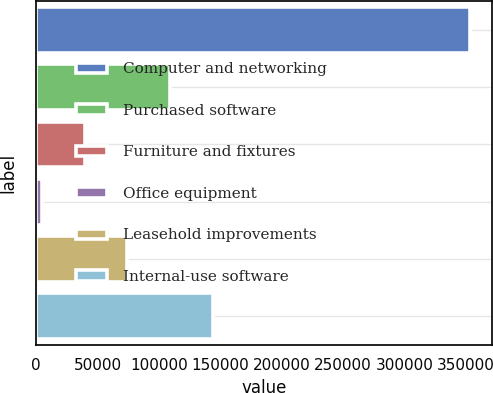<chart> <loc_0><loc_0><loc_500><loc_500><bar_chart><fcel>Computer and networking<fcel>Purchased software<fcel>Furniture and fixtures<fcel>Office equipment<fcel>Leasehold improvements<fcel>Internal-use software<nl><fcel>353375<fcel>109148<fcel>39368.6<fcel>4479<fcel>74258.2<fcel>144037<nl></chart> 